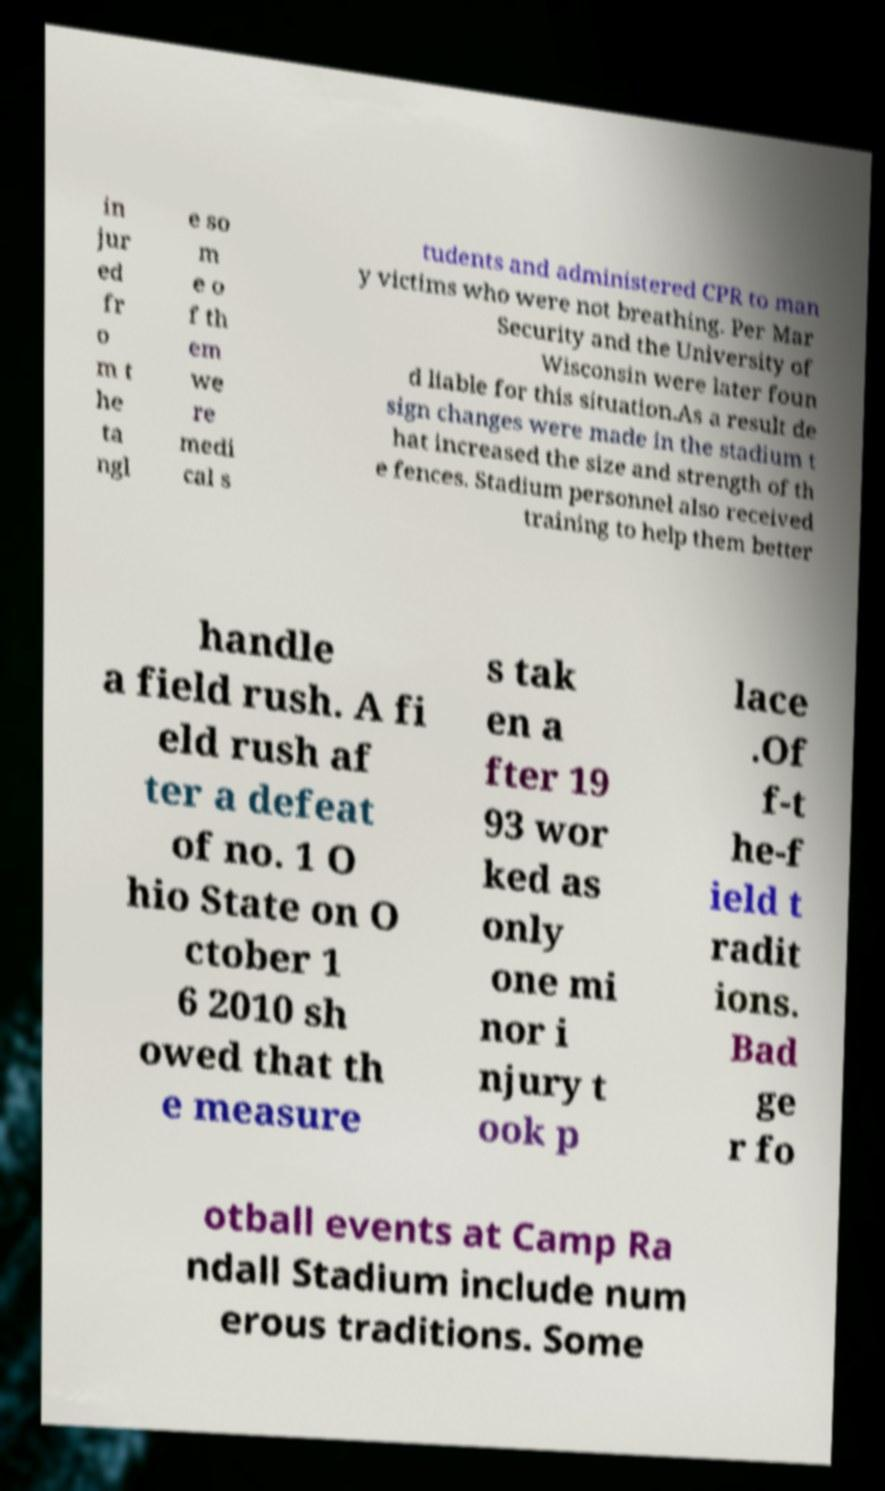Can you read and provide the text displayed in the image?This photo seems to have some interesting text. Can you extract and type it out for me? in jur ed fr o m t he ta ngl e so m e o f th em we re medi cal s tudents and administered CPR to man y victims who were not breathing. Per Mar Security and the University of Wisconsin were later foun d liable for this situation.As a result de sign changes were made in the stadium t hat increased the size and strength of th e fences. Stadium personnel also received training to help them better handle a field rush. A fi eld rush af ter a defeat of no. 1 O hio State on O ctober 1 6 2010 sh owed that th e measure s tak en a fter 19 93 wor ked as only one mi nor i njury t ook p lace .Of f-t he-f ield t radit ions. Bad ge r fo otball events at Camp Ra ndall Stadium include num erous traditions. Some 